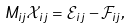<formula> <loc_0><loc_0><loc_500><loc_500>M _ { i j } \mathcal { X } _ { i j } = \mathcal { E } _ { i j } - \mathcal { F } _ { i j } ,</formula> 